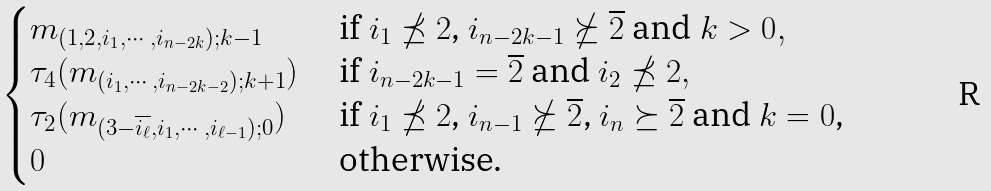<formula> <loc_0><loc_0><loc_500><loc_500>\begin{cases} m _ { ( 1 , 2 , i _ { 1 } , \cdots , i _ { n - 2 k } ) ; k - 1 } & \text { if $i_{1} \npreceq 2$, $i_{n-2k-1}\nsucceq \overline{2}$ and $k > 0$} , \\ \tau _ { 4 } ( m _ { ( i _ { 1 } , \cdots , i _ { n - 2 k - 2 } ) ; k + 1 } ) & \text { if $i_{n-2k-1} = \overline{2}$ and $i_{2}\npreceq 2$} , \\ \tau _ { 2 } ( m _ { ( 3 - \overline { i _ { \ell } } , i _ { 1 } , \cdots , i _ { \ell - 1 } ) ; 0 } ) & \text { if $i_{1} \npreceq 2$, $i_{n-1}\nsucceq \overline{2}$, $i_{n}\succeq \overline{2}$ and $k = 0$,} \\ 0 & \text { otherwise.} \end{cases}</formula> 